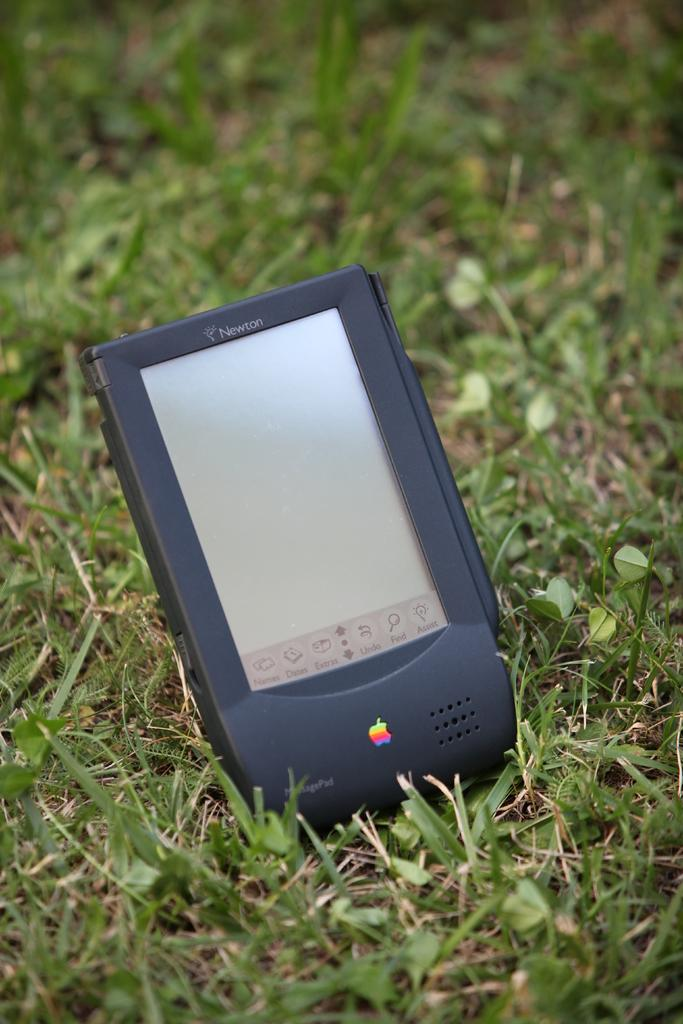What type of vegetation is present in the image? There is grass in the image. What kind of electronic gadget can be seen in the image? There is a black color electronic gadget in the image. What type of soup is being served in the basket in the image? There is no basket or soup present in the image. How does the electronic gadget provide comfort to the viewer in the image? The electronic gadget does not provide comfort to the viewer in the image, as it is not an interactive object. 